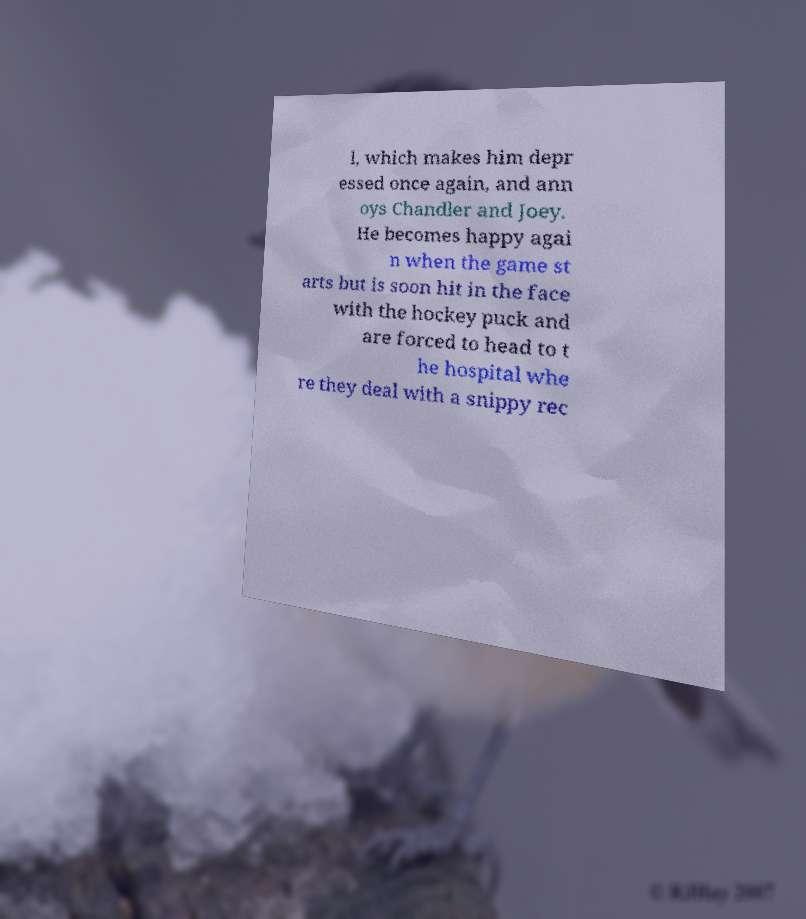There's text embedded in this image that I need extracted. Can you transcribe it verbatim? l, which makes him depr essed once again, and ann oys Chandler and Joey. He becomes happy agai n when the game st arts but is soon hit in the face with the hockey puck and are forced to head to t he hospital whe re they deal with a snippy rec 